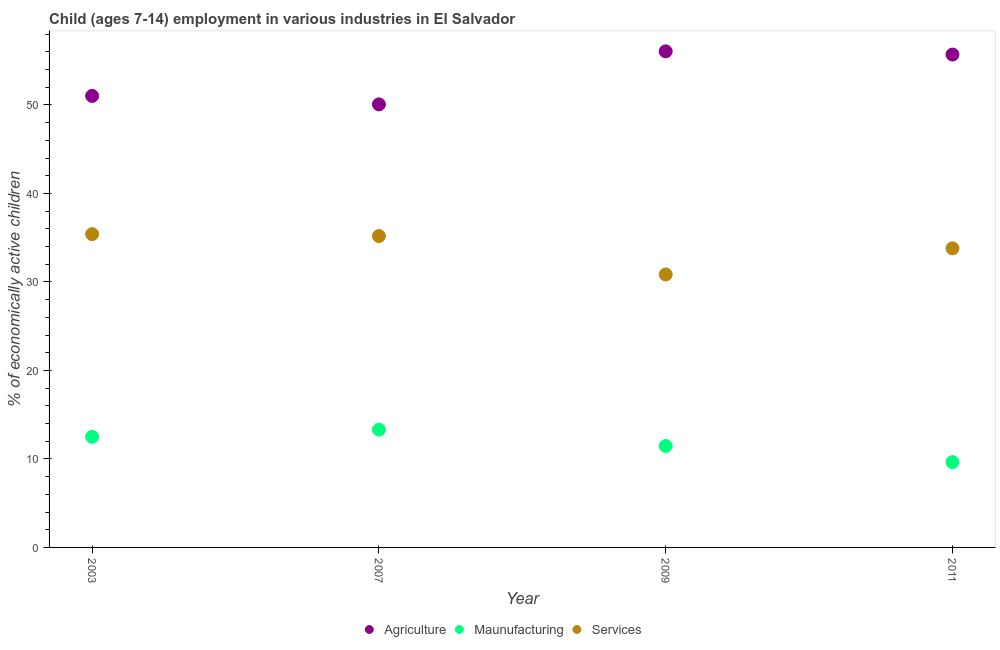How many different coloured dotlines are there?
Offer a terse response. 3. What is the percentage of economically active children in services in 2011?
Ensure brevity in your answer.  33.8. Across all years, what is the maximum percentage of economically active children in manufacturing?
Offer a terse response. 13.31. Across all years, what is the minimum percentage of economically active children in services?
Your response must be concise. 30.85. In which year was the percentage of economically active children in manufacturing minimum?
Your response must be concise. 2011. What is the total percentage of economically active children in manufacturing in the graph?
Your response must be concise. 46.92. What is the difference between the percentage of economically active children in services in 2007 and that in 2009?
Make the answer very short. 4.34. What is the difference between the percentage of economically active children in agriculture in 2011 and the percentage of economically active children in manufacturing in 2007?
Your answer should be very brief. 42.39. What is the average percentage of economically active children in manufacturing per year?
Give a very brief answer. 11.73. In the year 2009, what is the difference between the percentage of economically active children in services and percentage of economically active children in agriculture?
Your answer should be very brief. -25.21. What is the ratio of the percentage of economically active children in services in 2003 to that in 2011?
Offer a terse response. 1.05. Is the percentage of economically active children in manufacturing in 2007 less than that in 2011?
Offer a terse response. No. Is the difference between the percentage of economically active children in manufacturing in 2003 and 2011 greater than the difference between the percentage of economically active children in services in 2003 and 2011?
Provide a succinct answer. Yes. What is the difference between the highest and the second highest percentage of economically active children in manufacturing?
Keep it short and to the point. 0.81. What is the difference between the highest and the lowest percentage of economically active children in manufacturing?
Give a very brief answer. 3.67. In how many years, is the percentage of economically active children in services greater than the average percentage of economically active children in services taken over all years?
Provide a short and direct response. 2. Is the sum of the percentage of economically active children in manufacturing in 2003 and 2007 greater than the maximum percentage of economically active children in agriculture across all years?
Your answer should be very brief. No. Is the percentage of economically active children in manufacturing strictly less than the percentage of economically active children in agriculture over the years?
Your response must be concise. Yes. How many dotlines are there?
Give a very brief answer. 3. How many years are there in the graph?
Offer a very short reply. 4. What is the difference between two consecutive major ticks on the Y-axis?
Give a very brief answer. 10. How many legend labels are there?
Provide a short and direct response. 3. What is the title of the graph?
Keep it short and to the point. Child (ages 7-14) employment in various industries in El Salvador. Does "Agricultural raw materials" appear as one of the legend labels in the graph?
Ensure brevity in your answer.  No. What is the label or title of the X-axis?
Make the answer very short. Year. What is the label or title of the Y-axis?
Your response must be concise. % of economically active children. What is the % of economically active children of Agriculture in 2003?
Ensure brevity in your answer.  51.03. What is the % of economically active children of Maunufacturing in 2003?
Provide a succinct answer. 12.5. What is the % of economically active children of Services in 2003?
Offer a very short reply. 35.4. What is the % of economically active children of Agriculture in 2007?
Provide a succinct answer. 50.07. What is the % of economically active children in Maunufacturing in 2007?
Ensure brevity in your answer.  13.31. What is the % of economically active children in Services in 2007?
Offer a very short reply. 35.19. What is the % of economically active children of Agriculture in 2009?
Make the answer very short. 56.06. What is the % of economically active children of Maunufacturing in 2009?
Give a very brief answer. 11.47. What is the % of economically active children in Services in 2009?
Ensure brevity in your answer.  30.85. What is the % of economically active children in Agriculture in 2011?
Offer a terse response. 55.7. What is the % of economically active children in Maunufacturing in 2011?
Provide a short and direct response. 9.64. What is the % of economically active children of Services in 2011?
Provide a short and direct response. 33.8. Across all years, what is the maximum % of economically active children of Agriculture?
Your response must be concise. 56.06. Across all years, what is the maximum % of economically active children in Maunufacturing?
Make the answer very short. 13.31. Across all years, what is the maximum % of economically active children in Services?
Ensure brevity in your answer.  35.4. Across all years, what is the minimum % of economically active children in Agriculture?
Keep it short and to the point. 50.07. Across all years, what is the minimum % of economically active children of Maunufacturing?
Make the answer very short. 9.64. Across all years, what is the minimum % of economically active children of Services?
Your answer should be very brief. 30.85. What is the total % of economically active children in Agriculture in the graph?
Your answer should be compact. 212.86. What is the total % of economically active children of Maunufacturing in the graph?
Keep it short and to the point. 46.92. What is the total % of economically active children of Services in the graph?
Make the answer very short. 135.24. What is the difference between the % of economically active children of Agriculture in 2003 and that in 2007?
Offer a very short reply. 0.96. What is the difference between the % of economically active children in Maunufacturing in 2003 and that in 2007?
Provide a short and direct response. -0.81. What is the difference between the % of economically active children of Services in 2003 and that in 2007?
Your response must be concise. 0.21. What is the difference between the % of economically active children in Agriculture in 2003 and that in 2009?
Ensure brevity in your answer.  -5.03. What is the difference between the % of economically active children of Services in 2003 and that in 2009?
Ensure brevity in your answer.  4.55. What is the difference between the % of economically active children in Agriculture in 2003 and that in 2011?
Keep it short and to the point. -4.67. What is the difference between the % of economically active children of Maunufacturing in 2003 and that in 2011?
Provide a short and direct response. 2.86. What is the difference between the % of economically active children of Services in 2003 and that in 2011?
Your answer should be compact. 1.6. What is the difference between the % of economically active children of Agriculture in 2007 and that in 2009?
Give a very brief answer. -5.99. What is the difference between the % of economically active children of Maunufacturing in 2007 and that in 2009?
Keep it short and to the point. 1.84. What is the difference between the % of economically active children of Services in 2007 and that in 2009?
Your response must be concise. 4.34. What is the difference between the % of economically active children of Agriculture in 2007 and that in 2011?
Provide a short and direct response. -5.63. What is the difference between the % of economically active children of Maunufacturing in 2007 and that in 2011?
Provide a succinct answer. 3.67. What is the difference between the % of economically active children of Services in 2007 and that in 2011?
Offer a terse response. 1.39. What is the difference between the % of economically active children in Agriculture in 2009 and that in 2011?
Offer a terse response. 0.36. What is the difference between the % of economically active children of Maunufacturing in 2009 and that in 2011?
Make the answer very short. 1.83. What is the difference between the % of economically active children of Services in 2009 and that in 2011?
Ensure brevity in your answer.  -2.95. What is the difference between the % of economically active children of Agriculture in 2003 and the % of economically active children of Maunufacturing in 2007?
Make the answer very short. 37.72. What is the difference between the % of economically active children of Agriculture in 2003 and the % of economically active children of Services in 2007?
Give a very brief answer. 15.84. What is the difference between the % of economically active children of Maunufacturing in 2003 and the % of economically active children of Services in 2007?
Offer a very short reply. -22.69. What is the difference between the % of economically active children in Agriculture in 2003 and the % of economically active children in Maunufacturing in 2009?
Your answer should be very brief. 39.56. What is the difference between the % of economically active children of Agriculture in 2003 and the % of economically active children of Services in 2009?
Your answer should be very brief. 20.18. What is the difference between the % of economically active children in Maunufacturing in 2003 and the % of economically active children in Services in 2009?
Ensure brevity in your answer.  -18.35. What is the difference between the % of economically active children in Agriculture in 2003 and the % of economically active children in Maunufacturing in 2011?
Offer a very short reply. 41.39. What is the difference between the % of economically active children of Agriculture in 2003 and the % of economically active children of Services in 2011?
Give a very brief answer. 17.23. What is the difference between the % of economically active children of Maunufacturing in 2003 and the % of economically active children of Services in 2011?
Your answer should be compact. -21.3. What is the difference between the % of economically active children of Agriculture in 2007 and the % of economically active children of Maunufacturing in 2009?
Your response must be concise. 38.6. What is the difference between the % of economically active children of Agriculture in 2007 and the % of economically active children of Services in 2009?
Your answer should be compact. 19.22. What is the difference between the % of economically active children in Maunufacturing in 2007 and the % of economically active children in Services in 2009?
Offer a very short reply. -17.54. What is the difference between the % of economically active children in Agriculture in 2007 and the % of economically active children in Maunufacturing in 2011?
Keep it short and to the point. 40.43. What is the difference between the % of economically active children in Agriculture in 2007 and the % of economically active children in Services in 2011?
Your answer should be compact. 16.27. What is the difference between the % of economically active children of Maunufacturing in 2007 and the % of economically active children of Services in 2011?
Make the answer very short. -20.49. What is the difference between the % of economically active children in Agriculture in 2009 and the % of economically active children in Maunufacturing in 2011?
Your answer should be compact. 46.42. What is the difference between the % of economically active children in Agriculture in 2009 and the % of economically active children in Services in 2011?
Your answer should be very brief. 22.26. What is the difference between the % of economically active children in Maunufacturing in 2009 and the % of economically active children in Services in 2011?
Offer a terse response. -22.33. What is the average % of economically active children of Agriculture per year?
Your answer should be very brief. 53.21. What is the average % of economically active children of Maunufacturing per year?
Your response must be concise. 11.73. What is the average % of economically active children in Services per year?
Your answer should be very brief. 33.81. In the year 2003, what is the difference between the % of economically active children in Agriculture and % of economically active children in Maunufacturing?
Provide a succinct answer. 38.53. In the year 2003, what is the difference between the % of economically active children in Agriculture and % of economically active children in Services?
Ensure brevity in your answer.  15.62. In the year 2003, what is the difference between the % of economically active children in Maunufacturing and % of economically active children in Services?
Provide a short and direct response. -22.9. In the year 2007, what is the difference between the % of economically active children in Agriculture and % of economically active children in Maunufacturing?
Provide a short and direct response. 36.76. In the year 2007, what is the difference between the % of economically active children in Agriculture and % of economically active children in Services?
Ensure brevity in your answer.  14.88. In the year 2007, what is the difference between the % of economically active children in Maunufacturing and % of economically active children in Services?
Ensure brevity in your answer.  -21.88. In the year 2009, what is the difference between the % of economically active children of Agriculture and % of economically active children of Maunufacturing?
Offer a very short reply. 44.59. In the year 2009, what is the difference between the % of economically active children of Agriculture and % of economically active children of Services?
Make the answer very short. 25.21. In the year 2009, what is the difference between the % of economically active children in Maunufacturing and % of economically active children in Services?
Your response must be concise. -19.38. In the year 2011, what is the difference between the % of economically active children of Agriculture and % of economically active children of Maunufacturing?
Give a very brief answer. 46.06. In the year 2011, what is the difference between the % of economically active children in Agriculture and % of economically active children in Services?
Provide a succinct answer. 21.9. In the year 2011, what is the difference between the % of economically active children in Maunufacturing and % of economically active children in Services?
Your answer should be compact. -24.16. What is the ratio of the % of economically active children of Agriculture in 2003 to that in 2007?
Offer a terse response. 1.02. What is the ratio of the % of economically active children in Maunufacturing in 2003 to that in 2007?
Your answer should be compact. 0.94. What is the ratio of the % of economically active children in Services in 2003 to that in 2007?
Give a very brief answer. 1.01. What is the ratio of the % of economically active children of Agriculture in 2003 to that in 2009?
Your response must be concise. 0.91. What is the ratio of the % of economically active children in Maunufacturing in 2003 to that in 2009?
Provide a short and direct response. 1.09. What is the ratio of the % of economically active children in Services in 2003 to that in 2009?
Provide a short and direct response. 1.15. What is the ratio of the % of economically active children in Agriculture in 2003 to that in 2011?
Provide a succinct answer. 0.92. What is the ratio of the % of economically active children of Maunufacturing in 2003 to that in 2011?
Keep it short and to the point. 1.3. What is the ratio of the % of economically active children in Services in 2003 to that in 2011?
Offer a very short reply. 1.05. What is the ratio of the % of economically active children in Agriculture in 2007 to that in 2009?
Provide a short and direct response. 0.89. What is the ratio of the % of economically active children of Maunufacturing in 2007 to that in 2009?
Provide a short and direct response. 1.16. What is the ratio of the % of economically active children in Services in 2007 to that in 2009?
Your answer should be very brief. 1.14. What is the ratio of the % of economically active children of Agriculture in 2007 to that in 2011?
Keep it short and to the point. 0.9. What is the ratio of the % of economically active children of Maunufacturing in 2007 to that in 2011?
Give a very brief answer. 1.38. What is the ratio of the % of economically active children in Services in 2007 to that in 2011?
Your answer should be very brief. 1.04. What is the ratio of the % of economically active children in Maunufacturing in 2009 to that in 2011?
Your answer should be compact. 1.19. What is the ratio of the % of economically active children in Services in 2009 to that in 2011?
Your answer should be compact. 0.91. What is the difference between the highest and the second highest % of economically active children of Agriculture?
Provide a succinct answer. 0.36. What is the difference between the highest and the second highest % of economically active children in Maunufacturing?
Ensure brevity in your answer.  0.81. What is the difference between the highest and the second highest % of economically active children of Services?
Give a very brief answer. 0.21. What is the difference between the highest and the lowest % of economically active children in Agriculture?
Ensure brevity in your answer.  5.99. What is the difference between the highest and the lowest % of economically active children in Maunufacturing?
Your answer should be compact. 3.67. What is the difference between the highest and the lowest % of economically active children in Services?
Offer a terse response. 4.55. 